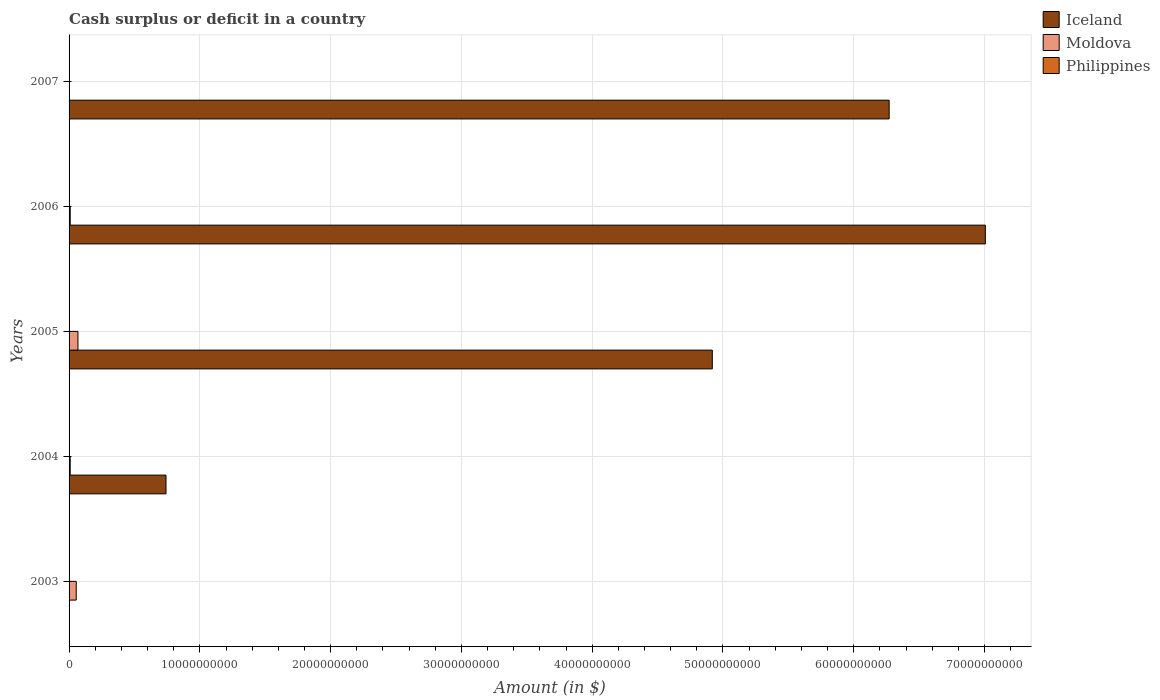How many different coloured bars are there?
Your response must be concise. 2. Are the number of bars per tick equal to the number of legend labels?
Give a very brief answer. No. Are the number of bars on each tick of the Y-axis equal?
Provide a short and direct response. No. How many bars are there on the 3rd tick from the top?
Give a very brief answer. 2. How many bars are there on the 1st tick from the bottom?
Offer a very short reply. 1. What is the amount of cash surplus or deficit in Moldova in 2004?
Your answer should be very brief. 8.61e+07. Across all years, what is the maximum amount of cash surplus or deficit in Moldova?
Make the answer very short. 6.79e+08. Across all years, what is the minimum amount of cash surplus or deficit in Philippines?
Offer a terse response. 0. What is the total amount of cash surplus or deficit in Moldova in the graph?
Ensure brevity in your answer.  1.40e+09. What is the difference between the amount of cash surplus or deficit in Moldova in 2003 and that in 2005?
Offer a very short reply. -1.31e+08. What is the difference between the amount of cash surplus or deficit in Moldova in 2006 and the amount of cash surplus or deficit in Philippines in 2005?
Ensure brevity in your answer.  8.75e+07. What is the average amount of cash surplus or deficit in Moldova per year?
Give a very brief answer. 2.80e+08. In the year 2006, what is the difference between the amount of cash surplus or deficit in Iceland and amount of cash surplus or deficit in Moldova?
Provide a succinct answer. 7.00e+1. In how many years, is the amount of cash surplus or deficit in Iceland greater than 38000000000 $?
Give a very brief answer. 3. What is the ratio of the amount of cash surplus or deficit in Moldova in 2005 to that in 2006?
Ensure brevity in your answer.  7.76. Is the difference between the amount of cash surplus or deficit in Iceland in 2004 and 2005 greater than the difference between the amount of cash surplus or deficit in Moldova in 2004 and 2005?
Offer a very short reply. No. What is the difference between the highest and the second highest amount of cash surplus or deficit in Moldova?
Keep it short and to the point. 1.31e+08. What is the difference between the highest and the lowest amount of cash surplus or deficit in Iceland?
Ensure brevity in your answer.  7.01e+1. In how many years, is the amount of cash surplus or deficit in Philippines greater than the average amount of cash surplus or deficit in Philippines taken over all years?
Your response must be concise. 0. Is it the case that in every year, the sum of the amount of cash surplus or deficit in Philippines and amount of cash surplus or deficit in Moldova is greater than the amount of cash surplus or deficit in Iceland?
Your answer should be compact. No. Are all the bars in the graph horizontal?
Make the answer very short. Yes. What is the difference between two consecutive major ticks on the X-axis?
Give a very brief answer. 1.00e+1. Does the graph contain any zero values?
Your response must be concise. Yes. Does the graph contain grids?
Provide a short and direct response. Yes. Where does the legend appear in the graph?
Offer a terse response. Top right. How are the legend labels stacked?
Your response must be concise. Vertical. What is the title of the graph?
Give a very brief answer. Cash surplus or deficit in a country. What is the label or title of the X-axis?
Your answer should be very brief. Amount (in $). What is the label or title of the Y-axis?
Your answer should be very brief. Years. What is the Amount (in $) of Iceland in 2003?
Offer a terse response. 0. What is the Amount (in $) of Moldova in 2003?
Keep it short and to the point. 5.48e+08. What is the Amount (in $) of Philippines in 2003?
Offer a very short reply. 0. What is the Amount (in $) of Iceland in 2004?
Ensure brevity in your answer.  7.41e+09. What is the Amount (in $) in Moldova in 2004?
Give a very brief answer. 8.61e+07. What is the Amount (in $) of Philippines in 2004?
Your answer should be very brief. 0. What is the Amount (in $) in Iceland in 2005?
Your answer should be very brief. 4.92e+1. What is the Amount (in $) of Moldova in 2005?
Offer a terse response. 6.79e+08. What is the Amount (in $) of Iceland in 2006?
Your answer should be compact. 7.01e+1. What is the Amount (in $) in Moldova in 2006?
Your answer should be very brief. 8.75e+07. What is the Amount (in $) in Philippines in 2006?
Offer a very short reply. 0. What is the Amount (in $) of Iceland in 2007?
Ensure brevity in your answer.  6.27e+1. What is the Amount (in $) of Moldova in 2007?
Your answer should be compact. 0. What is the Amount (in $) in Philippines in 2007?
Ensure brevity in your answer.  0. Across all years, what is the maximum Amount (in $) of Iceland?
Make the answer very short. 7.01e+1. Across all years, what is the maximum Amount (in $) in Moldova?
Your answer should be very brief. 6.79e+08. Across all years, what is the minimum Amount (in $) of Moldova?
Your answer should be very brief. 0. What is the total Amount (in $) of Iceland in the graph?
Your response must be concise. 1.89e+11. What is the total Amount (in $) of Moldova in the graph?
Ensure brevity in your answer.  1.40e+09. What is the difference between the Amount (in $) in Moldova in 2003 and that in 2004?
Offer a very short reply. 4.62e+08. What is the difference between the Amount (in $) in Moldova in 2003 and that in 2005?
Provide a succinct answer. -1.31e+08. What is the difference between the Amount (in $) in Moldova in 2003 and that in 2006?
Ensure brevity in your answer.  4.61e+08. What is the difference between the Amount (in $) of Iceland in 2004 and that in 2005?
Make the answer very short. -4.18e+1. What is the difference between the Amount (in $) in Moldova in 2004 and that in 2005?
Ensure brevity in your answer.  -5.93e+08. What is the difference between the Amount (in $) in Iceland in 2004 and that in 2006?
Provide a short and direct response. -6.27e+1. What is the difference between the Amount (in $) of Moldova in 2004 and that in 2006?
Give a very brief answer. -1.40e+06. What is the difference between the Amount (in $) of Iceland in 2004 and that in 2007?
Offer a very short reply. -5.53e+1. What is the difference between the Amount (in $) of Iceland in 2005 and that in 2006?
Make the answer very short. -2.09e+1. What is the difference between the Amount (in $) of Moldova in 2005 and that in 2006?
Provide a short and direct response. 5.92e+08. What is the difference between the Amount (in $) of Iceland in 2005 and that in 2007?
Your response must be concise. -1.35e+1. What is the difference between the Amount (in $) in Iceland in 2006 and that in 2007?
Your answer should be compact. 7.36e+09. What is the difference between the Amount (in $) of Iceland in 2004 and the Amount (in $) of Moldova in 2005?
Your response must be concise. 6.73e+09. What is the difference between the Amount (in $) of Iceland in 2004 and the Amount (in $) of Moldova in 2006?
Offer a very short reply. 7.33e+09. What is the difference between the Amount (in $) in Iceland in 2005 and the Amount (in $) in Moldova in 2006?
Provide a succinct answer. 4.91e+1. What is the average Amount (in $) of Iceland per year?
Provide a short and direct response. 3.79e+1. What is the average Amount (in $) in Moldova per year?
Offer a very short reply. 2.80e+08. What is the average Amount (in $) of Philippines per year?
Your answer should be compact. 0. In the year 2004, what is the difference between the Amount (in $) of Iceland and Amount (in $) of Moldova?
Your answer should be compact. 7.33e+09. In the year 2005, what is the difference between the Amount (in $) of Iceland and Amount (in $) of Moldova?
Provide a short and direct response. 4.85e+1. In the year 2006, what is the difference between the Amount (in $) of Iceland and Amount (in $) of Moldova?
Your answer should be very brief. 7.00e+1. What is the ratio of the Amount (in $) in Moldova in 2003 to that in 2004?
Make the answer very short. 6.37. What is the ratio of the Amount (in $) in Moldova in 2003 to that in 2005?
Offer a very short reply. 0.81. What is the ratio of the Amount (in $) of Moldova in 2003 to that in 2006?
Give a very brief answer. 6.27. What is the ratio of the Amount (in $) in Iceland in 2004 to that in 2005?
Provide a succinct answer. 0.15. What is the ratio of the Amount (in $) in Moldova in 2004 to that in 2005?
Your answer should be compact. 0.13. What is the ratio of the Amount (in $) of Iceland in 2004 to that in 2006?
Your response must be concise. 0.11. What is the ratio of the Amount (in $) of Moldova in 2004 to that in 2006?
Your answer should be compact. 0.98. What is the ratio of the Amount (in $) in Iceland in 2004 to that in 2007?
Offer a terse response. 0.12. What is the ratio of the Amount (in $) of Iceland in 2005 to that in 2006?
Ensure brevity in your answer.  0.7. What is the ratio of the Amount (in $) in Moldova in 2005 to that in 2006?
Your answer should be compact. 7.76. What is the ratio of the Amount (in $) of Iceland in 2005 to that in 2007?
Your response must be concise. 0.78. What is the ratio of the Amount (in $) of Iceland in 2006 to that in 2007?
Make the answer very short. 1.12. What is the difference between the highest and the second highest Amount (in $) in Iceland?
Keep it short and to the point. 7.36e+09. What is the difference between the highest and the second highest Amount (in $) in Moldova?
Provide a succinct answer. 1.31e+08. What is the difference between the highest and the lowest Amount (in $) in Iceland?
Give a very brief answer. 7.01e+1. What is the difference between the highest and the lowest Amount (in $) of Moldova?
Give a very brief answer. 6.79e+08. 